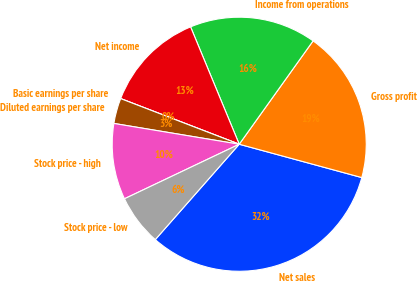Convert chart. <chart><loc_0><loc_0><loc_500><loc_500><pie_chart><fcel>Net sales<fcel>Gross profit<fcel>Income from operations<fcel>Net income<fcel>Basic earnings per share<fcel>Diluted earnings per share<fcel>Stock price - high<fcel>Stock price - low<nl><fcel>32.26%<fcel>19.35%<fcel>16.13%<fcel>12.9%<fcel>0.0%<fcel>3.23%<fcel>9.68%<fcel>6.45%<nl></chart> 